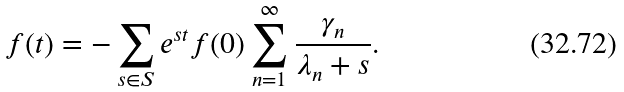<formula> <loc_0><loc_0><loc_500><loc_500>f ( t ) = - \sum _ { s \in S } e ^ { s t } f ( 0 ) \sum _ { n = 1 } ^ { \infty } \frac { \gamma _ { n } } { \lambda _ { n } + s } .</formula> 